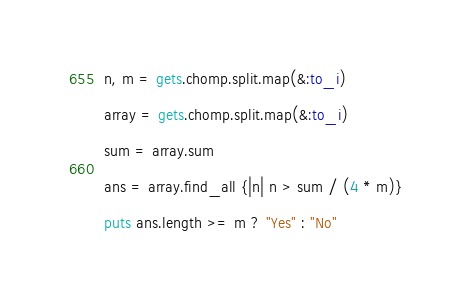Convert code to text. <code><loc_0><loc_0><loc_500><loc_500><_Ruby_>n, m = gets.chomp.split.map(&:to_i)

array = gets.chomp.split.map(&:to_i)

sum = array.sum

ans = array.find_all {|n| n > sum / (4 * m)}

puts ans.length >= m ? "Yes" : "No"
</code> 